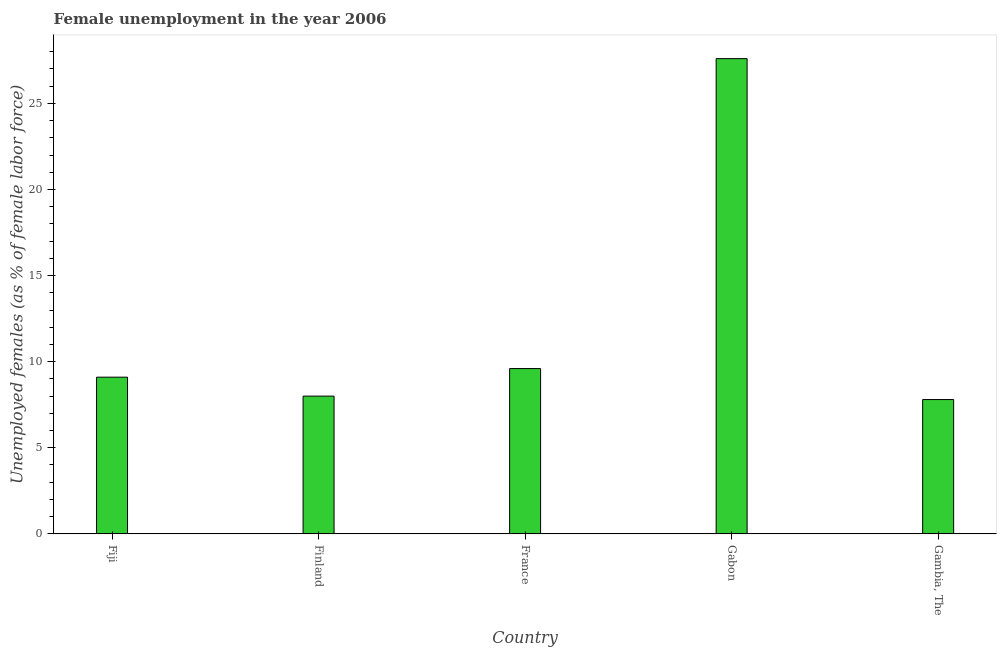Does the graph contain any zero values?
Your answer should be very brief. No. What is the title of the graph?
Offer a terse response. Female unemployment in the year 2006. What is the label or title of the Y-axis?
Your response must be concise. Unemployed females (as % of female labor force). What is the unemployed females population in Gambia, The?
Your answer should be compact. 7.8. Across all countries, what is the maximum unemployed females population?
Provide a short and direct response. 27.6. Across all countries, what is the minimum unemployed females population?
Give a very brief answer. 7.8. In which country was the unemployed females population maximum?
Your answer should be compact. Gabon. In which country was the unemployed females population minimum?
Make the answer very short. Gambia, The. What is the sum of the unemployed females population?
Offer a very short reply. 62.1. What is the difference between the unemployed females population in Fiji and France?
Provide a succinct answer. -0.5. What is the average unemployed females population per country?
Provide a short and direct response. 12.42. What is the median unemployed females population?
Offer a terse response. 9.1. In how many countries, is the unemployed females population greater than 22 %?
Your answer should be compact. 1. What is the ratio of the unemployed females population in France to that in Gabon?
Provide a succinct answer. 0.35. Is the unemployed females population in Gabon less than that in Gambia, The?
Offer a very short reply. No. What is the difference between the highest and the lowest unemployed females population?
Ensure brevity in your answer.  19.8. How many bars are there?
Your answer should be very brief. 5. What is the Unemployed females (as % of female labor force) in Fiji?
Your response must be concise. 9.1. What is the Unemployed females (as % of female labor force) in France?
Offer a very short reply. 9.6. What is the Unemployed females (as % of female labor force) of Gabon?
Ensure brevity in your answer.  27.6. What is the Unemployed females (as % of female labor force) in Gambia, The?
Provide a short and direct response. 7.8. What is the difference between the Unemployed females (as % of female labor force) in Fiji and France?
Ensure brevity in your answer.  -0.5. What is the difference between the Unemployed females (as % of female labor force) in Fiji and Gabon?
Give a very brief answer. -18.5. What is the difference between the Unemployed females (as % of female labor force) in Fiji and Gambia, The?
Offer a terse response. 1.3. What is the difference between the Unemployed females (as % of female labor force) in Finland and Gabon?
Offer a very short reply. -19.6. What is the difference between the Unemployed females (as % of female labor force) in Finland and Gambia, The?
Ensure brevity in your answer.  0.2. What is the difference between the Unemployed females (as % of female labor force) in France and Gambia, The?
Your answer should be compact. 1.8. What is the difference between the Unemployed females (as % of female labor force) in Gabon and Gambia, The?
Provide a short and direct response. 19.8. What is the ratio of the Unemployed females (as % of female labor force) in Fiji to that in Finland?
Ensure brevity in your answer.  1.14. What is the ratio of the Unemployed females (as % of female labor force) in Fiji to that in France?
Your answer should be very brief. 0.95. What is the ratio of the Unemployed females (as % of female labor force) in Fiji to that in Gabon?
Offer a very short reply. 0.33. What is the ratio of the Unemployed females (as % of female labor force) in Fiji to that in Gambia, The?
Keep it short and to the point. 1.17. What is the ratio of the Unemployed females (as % of female labor force) in Finland to that in France?
Your response must be concise. 0.83. What is the ratio of the Unemployed females (as % of female labor force) in Finland to that in Gabon?
Provide a succinct answer. 0.29. What is the ratio of the Unemployed females (as % of female labor force) in France to that in Gabon?
Make the answer very short. 0.35. What is the ratio of the Unemployed females (as % of female labor force) in France to that in Gambia, The?
Provide a short and direct response. 1.23. What is the ratio of the Unemployed females (as % of female labor force) in Gabon to that in Gambia, The?
Provide a succinct answer. 3.54. 